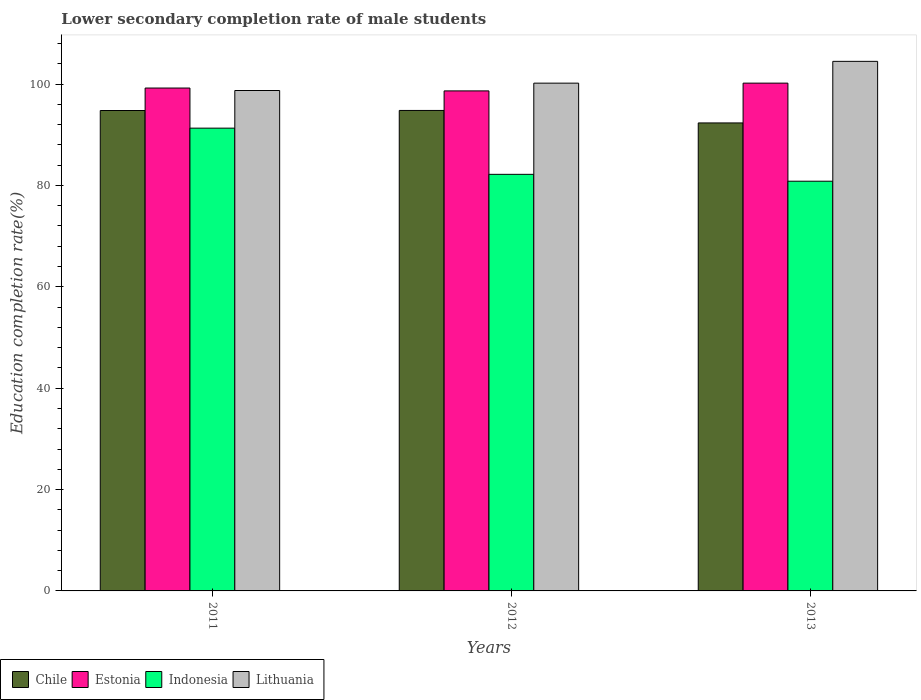How many different coloured bars are there?
Your answer should be very brief. 4. In how many cases, is the number of bars for a given year not equal to the number of legend labels?
Provide a succinct answer. 0. What is the lower secondary completion rate of male students in Lithuania in 2011?
Your response must be concise. 98.73. Across all years, what is the maximum lower secondary completion rate of male students in Indonesia?
Offer a terse response. 91.3. Across all years, what is the minimum lower secondary completion rate of male students in Chile?
Provide a succinct answer. 92.33. In which year was the lower secondary completion rate of male students in Chile maximum?
Your answer should be compact. 2012. What is the total lower secondary completion rate of male students in Estonia in the graph?
Keep it short and to the point. 298.06. What is the difference between the lower secondary completion rate of male students in Lithuania in 2012 and that in 2013?
Provide a short and direct response. -4.3. What is the difference between the lower secondary completion rate of male students in Chile in 2011 and the lower secondary completion rate of male students in Estonia in 2012?
Ensure brevity in your answer.  -3.87. What is the average lower secondary completion rate of male students in Chile per year?
Your answer should be compact. 93.97. In the year 2011, what is the difference between the lower secondary completion rate of male students in Estonia and lower secondary completion rate of male students in Indonesia?
Give a very brief answer. 7.91. What is the ratio of the lower secondary completion rate of male students in Indonesia in 2011 to that in 2013?
Give a very brief answer. 1.13. Is the difference between the lower secondary completion rate of male students in Estonia in 2011 and 2013 greater than the difference between the lower secondary completion rate of male students in Indonesia in 2011 and 2013?
Your response must be concise. No. What is the difference between the highest and the second highest lower secondary completion rate of male students in Estonia?
Keep it short and to the point. 0.97. What is the difference between the highest and the lowest lower secondary completion rate of male students in Indonesia?
Keep it short and to the point. 10.47. In how many years, is the lower secondary completion rate of male students in Estonia greater than the average lower secondary completion rate of male students in Estonia taken over all years?
Ensure brevity in your answer.  1. What does the 4th bar from the right in 2013 represents?
Keep it short and to the point. Chile. Is it the case that in every year, the sum of the lower secondary completion rate of male students in Indonesia and lower secondary completion rate of male students in Chile is greater than the lower secondary completion rate of male students in Estonia?
Offer a terse response. Yes. How many bars are there?
Keep it short and to the point. 12. Are all the bars in the graph horizontal?
Offer a very short reply. No. How many years are there in the graph?
Your answer should be very brief. 3. What is the difference between two consecutive major ticks on the Y-axis?
Your answer should be compact. 20. Are the values on the major ticks of Y-axis written in scientific E-notation?
Your response must be concise. No. Does the graph contain any zero values?
Provide a succinct answer. No. Does the graph contain grids?
Offer a very short reply. No. Where does the legend appear in the graph?
Your answer should be compact. Bottom left. How many legend labels are there?
Your response must be concise. 4. What is the title of the graph?
Offer a terse response. Lower secondary completion rate of male students. Does "French Polynesia" appear as one of the legend labels in the graph?
Your answer should be compact. No. What is the label or title of the X-axis?
Provide a short and direct response. Years. What is the label or title of the Y-axis?
Make the answer very short. Education completion rate(%). What is the Education completion rate(%) in Chile in 2011?
Provide a short and direct response. 94.79. What is the Education completion rate(%) in Estonia in 2011?
Keep it short and to the point. 99.22. What is the Education completion rate(%) of Indonesia in 2011?
Your answer should be compact. 91.3. What is the Education completion rate(%) in Lithuania in 2011?
Your response must be concise. 98.73. What is the Education completion rate(%) of Chile in 2012?
Your answer should be very brief. 94.8. What is the Education completion rate(%) of Estonia in 2012?
Provide a short and direct response. 98.65. What is the Education completion rate(%) in Indonesia in 2012?
Make the answer very short. 82.19. What is the Education completion rate(%) in Lithuania in 2012?
Provide a succinct answer. 100.18. What is the Education completion rate(%) in Chile in 2013?
Keep it short and to the point. 92.33. What is the Education completion rate(%) in Estonia in 2013?
Your answer should be very brief. 100.19. What is the Education completion rate(%) in Indonesia in 2013?
Your response must be concise. 80.84. What is the Education completion rate(%) of Lithuania in 2013?
Offer a very short reply. 104.48. Across all years, what is the maximum Education completion rate(%) of Chile?
Your answer should be very brief. 94.8. Across all years, what is the maximum Education completion rate(%) in Estonia?
Give a very brief answer. 100.19. Across all years, what is the maximum Education completion rate(%) in Indonesia?
Give a very brief answer. 91.3. Across all years, what is the maximum Education completion rate(%) of Lithuania?
Your answer should be compact. 104.48. Across all years, what is the minimum Education completion rate(%) in Chile?
Offer a terse response. 92.33. Across all years, what is the minimum Education completion rate(%) in Estonia?
Offer a terse response. 98.65. Across all years, what is the minimum Education completion rate(%) in Indonesia?
Ensure brevity in your answer.  80.84. Across all years, what is the minimum Education completion rate(%) of Lithuania?
Your answer should be compact. 98.73. What is the total Education completion rate(%) of Chile in the graph?
Keep it short and to the point. 281.92. What is the total Education completion rate(%) of Estonia in the graph?
Your response must be concise. 298.06. What is the total Education completion rate(%) of Indonesia in the graph?
Your answer should be very brief. 254.33. What is the total Education completion rate(%) in Lithuania in the graph?
Provide a short and direct response. 303.4. What is the difference between the Education completion rate(%) in Chile in 2011 and that in 2012?
Offer a very short reply. -0.01. What is the difference between the Education completion rate(%) of Estonia in 2011 and that in 2012?
Your answer should be compact. 0.57. What is the difference between the Education completion rate(%) of Indonesia in 2011 and that in 2012?
Make the answer very short. 9.11. What is the difference between the Education completion rate(%) in Lithuania in 2011 and that in 2012?
Ensure brevity in your answer.  -1.45. What is the difference between the Education completion rate(%) of Chile in 2011 and that in 2013?
Your answer should be compact. 2.45. What is the difference between the Education completion rate(%) in Estonia in 2011 and that in 2013?
Ensure brevity in your answer.  -0.97. What is the difference between the Education completion rate(%) of Indonesia in 2011 and that in 2013?
Your answer should be compact. 10.47. What is the difference between the Education completion rate(%) in Lithuania in 2011 and that in 2013?
Make the answer very short. -5.75. What is the difference between the Education completion rate(%) in Chile in 2012 and that in 2013?
Your answer should be compact. 2.46. What is the difference between the Education completion rate(%) of Estonia in 2012 and that in 2013?
Provide a short and direct response. -1.53. What is the difference between the Education completion rate(%) of Indonesia in 2012 and that in 2013?
Keep it short and to the point. 1.36. What is the difference between the Education completion rate(%) in Lithuania in 2012 and that in 2013?
Ensure brevity in your answer.  -4.3. What is the difference between the Education completion rate(%) in Chile in 2011 and the Education completion rate(%) in Estonia in 2012?
Your answer should be compact. -3.87. What is the difference between the Education completion rate(%) in Chile in 2011 and the Education completion rate(%) in Indonesia in 2012?
Ensure brevity in your answer.  12.59. What is the difference between the Education completion rate(%) of Chile in 2011 and the Education completion rate(%) of Lithuania in 2012?
Provide a succinct answer. -5.4. What is the difference between the Education completion rate(%) of Estonia in 2011 and the Education completion rate(%) of Indonesia in 2012?
Offer a terse response. 17.03. What is the difference between the Education completion rate(%) in Estonia in 2011 and the Education completion rate(%) in Lithuania in 2012?
Give a very brief answer. -0.96. What is the difference between the Education completion rate(%) of Indonesia in 2011 and the Education completion rate(%) of Lithuania in 2012?
Make the answer very short. -8.88. What is the difference between the Education completion rate(%) of Chile in 2011 and the Education completion rate(%) of Estonia in 2013?
Give a very brief answer. -5.4. What is the difference between the Education completion rate(%) of Chile in 2011 and the Education completion rate(%) of Indonesia in 2013?
Ensure brevity in your answer.  13.95. What is the difference between the Education completion rate(%) of Chile in 2011 and the Education completion rate(%) of Lithuania in 2013?
Your answer should be very brief. -9.7. What is the difference between the Education completion rate(%) of Estonia in 2011 and the Education completion rate(%) of Indonesia in 2013?
Give a very brief answer. 18.38. What is the difference between the Education completion rate(%) of Estonia in 2011 and the Education completion rate(%) of Lithuania in 2013?
Give a very brief answer. -5.26. What is the difference between the Education completion rate(%) of Indonesia in 2011 and the Education completion rate(%) of Lithuania in 2013?
Offer a terse response. -13.18. What is the difference between the Education completion rate(%) in Chile in 2012 and the Education completion rate(%) in Estonia in 2013?
Offer a terse response. -5.39. What is the difference between the Education completion rate(%) in Chile in 2012 and the Education completion rate(%) in Indonesia in 2013?
Offer a terse response. 13.96. What is the difference between the Education completion rate(%) of Chile in 2012 and the Education completion rate(%) of Lithuania in 2013?
Keep it short and to the point. -9.69. What is the difference between the Education completion rate(%) in Estonia in 2012 and the Education completion rate(%) in Indonesia in 2013?
Make the answer very short. 17.82. What is the difference between the Education completion rate(%) in Estonia in 2012 and the Education completion rate(%) in Lithuania in 2013?
Offer a very short reply. -5.83. What is the difference between the Education completion rate(%) of Indonesia in 2012 and the Education completion rate(%) of Lithuania in 2013?
Provide a succinct answer. -22.29. What is the average Education completion rate(%) of Chile per year?
Provide a short and direct response. 93.97. What is the average Education completion rate(%) in Estonia per year?
Your answer should be very brief. 99.35. What is the average Education completion rate(%) of Indonesia per year?
Make the answer very short. 84.78. What is the average Education completion rate(%) of Lithuania per year?
Ensure brevity in your answer.  101.13. In the year 2011, what is the difference between the Education completion rate(%) of Chile and Education completion rate(%) of Estonia?
Make the answer very short. -4.43. In the year 2011, what is the difference between the Education completion rate(%) of Chile and Education completion rate(%) of Indonesia?
Make the answer very short. 3.48. In the year 2011, what is the difference between the Education completion rate(%) in Chile and Education completion rate(%) in Lithuania?
Give a very brief answer. -3.95. In the year 2011, what is the difference between the Education completion rate(%) in Estonia and Education completion rate(%) in Indonesia?
Your response must be concise. 7.91. In the year 2011, what is the difference between the Education completion rate(%) in Estonia and Education completion rate(%) in Lithuania?
Offer a terse response. 0.49. In the year 2011, what is the difference between the Education completion rate(%) of Indonesia and Education completion rate(%) of Lithuania?
Make the answer very short. -7.43. In the year 2012, what is the difference between the Education completion rate(%) of Chile and Education completion rate(%) of Estonia?
Your response must be concise. -3.86. In the year 2012, what is the difference between the Education completion rate(%) of Chile and Education completion rate(%) of Indonesia?
Your answer should be very brief. 12.6. In the year 2012, what is the difference between the Education completion rate(%) of Chile and Education completion rate(%) of Lithuania?
Your response must be concise. -5.39. In the year 2012, what is the difference between the Education completion rate(%) of Estonia and Education completion rate(%) of Indonesia?
Provide a short and direct response. 16.46. In the year 2012, what is the difference between the Education completion rate(%) in Estonia and Education completion rate(%) in Lithuania?
Your answer should be compact. -1.53. In the year 2012, what is the difference between the Education completion rate(%) in Indonesia and Education completion rate(%) in Lithuania?
Keep it short and to the point. -17.99. In the year 2013, what is the difference between the Education completion rate(%) of Chile and Education completion rate(%) of Estonia?
Give a very brief answer. -7.85. In the year 2013, what is the difference between the Education completion rate(%) in Chile and Education completion rate(%) in Indonesia?
Provide a short and direct response. 11.5. In the year 2013, what is the difference between the Education completion rate(%) of Chile and Education completion rate(%) of Lithuania?
Provide a succinct answer. -12.15. In the year 2013, what is the difference between the Education completion rate(%) of Estonia and Education completion rate(%) of Indonesia?
Provide a short and direct response. 19.35. In the year 2013, what is the difference between the Education completion rate(%) of Estonia and Education completion rate(%) of Lithuania?
Offer a very short reply. -4.3. In the year 2013, what is the difference between the Education completion rate(%) in Indonesia and Education completion rate(%) in Lithuania?
Give a very brief answer. -23.65. What is the ratio of the Education completion rate(%) in Indonesia in 2011 to that in 2012?
Your response must be concise. 1.11. What is the ratio of the Education completion rate(%) of Lithuania in 2011 to that in 2012?
Your response must be concise. 0.99. What is the ratio of the Education completion rate(%) in Chile in 2011 to that in 2013?
Your answer should be compact. 1.03. What is the ratio of the Education completion rate(%) in Estonia in 2011 to that in 2013?
Your answer should be compact. 0.99. What is the ratio of the Education completion rate(%) in Indonesia in 2011 to that in 2013?
Offer a very short reply. 1.13. What is the ratio of the Education completion rate(%) of Lithuania in 2011 to that in 2013?
Make the answer very short. 0.94. What is the ratio of the Education completion rate(%) in Chile in 2012 to that in 2013?
Your answer should be very brief. 1.03. What is the ratio of the Education completion rate(%) of Estonia in 2012 to that in 2013?
Make the answer very short. 0.98. What is the ratio of the Education completion rate(%) of Indonesia in 2012 to that in 2013?
Keep it short and to the point. 1.02. What is the ratio of the Education completion rate(%) in Lithuania in 2012 to that in 2013?
Your response must be concise. 0.96. What is the difference between the highest and the second highest Education completion rate(%) in Chile?
Provide a short and direct response. 0.01. What is the difference between the highest and the second highest Education completion rate(%) in Estonia?
Provide a succinct answer. 0.97. What is the difference between the highest and the second highest Education completion rate(%) in Indonesia?
Your answer should be very brief. 9.11. What is the difference between the highest and the second highest Education completion rate(%) in Lithuania?
Provide a short and direct response. 4.3. What is the difference between the highest and the lowest Education completion rate(%) of Chile?
Make the answer very short. 2.46. What is the difference between the highest and the lowest Education completion rate(%) of Estonia?
Ensure brevity in your answer.  1.53. What is the difference between the highest and the lowest Education completion rate(%) in Indonesia?
Give a very brief answer. 10.47. What is the difference between the highest and the lowest Education completion rate(%) of Lithuania?
Provide a succinct answer. 5.75. 